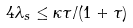Convert formula to latex. <formula><loc_0><loc_0><loc_500><loc_500>4 \lambda _ { s } \leq { \kappa \tau } / { ( 1 + \tau ) }</formula> 